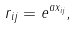<formula> <loc_0><loc_0><loc_500><loc_500>r _ { i j } = e ^ { a x _ { i j } } ,</formula> 